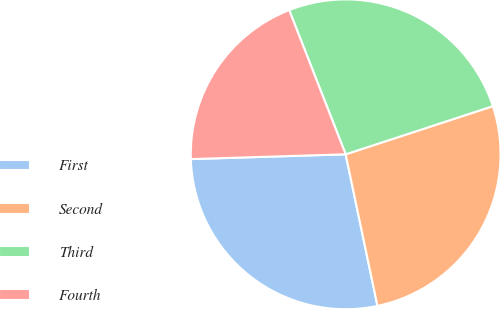Convert chart. <chart><loc_0><loc_0><loc_500><loc_500><pie_chart><fcel>First<fcel>Second<fcel>Third<fcel>Fourth<nl><fcel>27.8%<fcel>26.74%<fcel>25.91%<fcel>19.55%<nl></chart> 